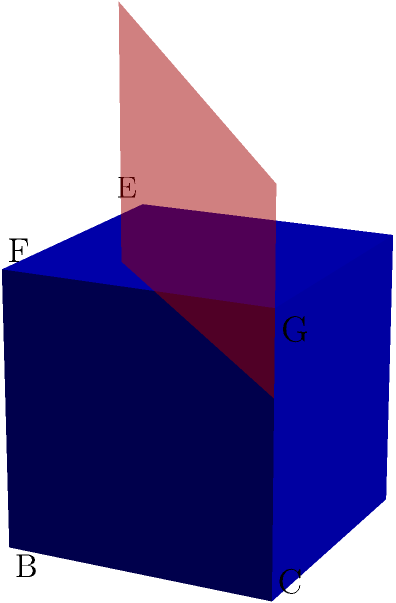In the context of studying the impact of humanities integration in STEM education, consider the following spatial reasoning task:

A unit cube ABCDEFGH is intersected by a plane parallel to the base at a height of 0.7 units from the base. What shape is formed by this intersection, and how does this relate to the concept of cross-disciplinary thinking in education? To solve this problem and relate it to cross-disciplinary thinking, let's follow these steps:

1. Visualize the cube:
   - The cube has a side length of 1 unit.
   - The base is ABCD, and the top face is EFGH.

2. Understand the cutting plane:
   - The plane is parallel to the base ABCD.
   - It's positioned at 0.7 units above the base.

3. Determine the shape of the intersection:
   - Since the plane is parallel to the base, it will create a shape similar to the base.
   - The base is a square, so the intersection will also be a square.

4. Calculate the side length of the resulting square:
   - The cutting plane is at 70% of the cube's height.
   - The resulting square will have sides that are 70% of the original cube's sides.
   - Side length of the intersection square = $1 * 0.7 = 0.7$ units

5. Relate to cross-disciplinary thinking in education:
   - This problem combines geometry (STEM) with spatial reasoning (a skill often developed through arts and design, part of humanities).
   - The ability to visualize 3D objects and their cross-sections is crucial in many STEM fields, but it's also a skill enhanced by studying art and design.
   - This intersection represents how skills from different disciplines (STEM and humanities) can combine to create a new perspective (the square cross-section).
   - Just as the cutting plane reveals a new view of the cube, integrating humanities into STEM education can reveal new insights and approaches to problem-solving.

6. Educational impact:
   - This type of spatial reasoning task could be used to assess how students' visual-spatial skills improve when exposed to an integrated STEM-humanities curriculum.
   - It demonstrates how abstract mathematical concepts (geometry) can be linked to real-world applications and creative thinking, potentially increasing student engagement and understanding.
Answer: A square with side length 0.7 units; represents integration of STEM and humanities skills. 